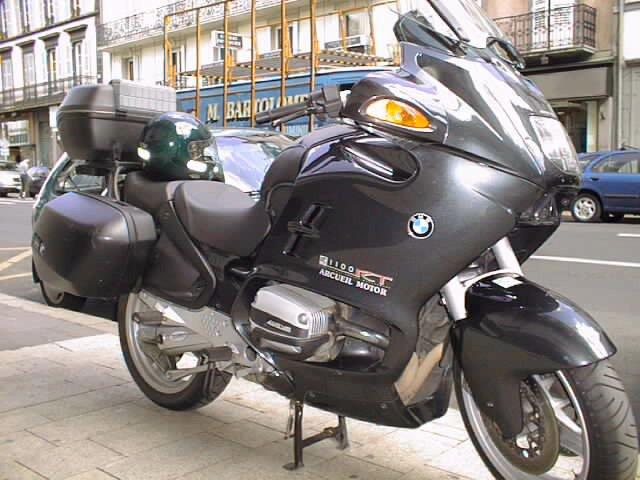What color is the motorcycle?
Concise answer only. Black. Is this a BMW motorcycle?
Answer briefly. Yes. Can you ride this motorcycle?
Answer briefly. Yes. 